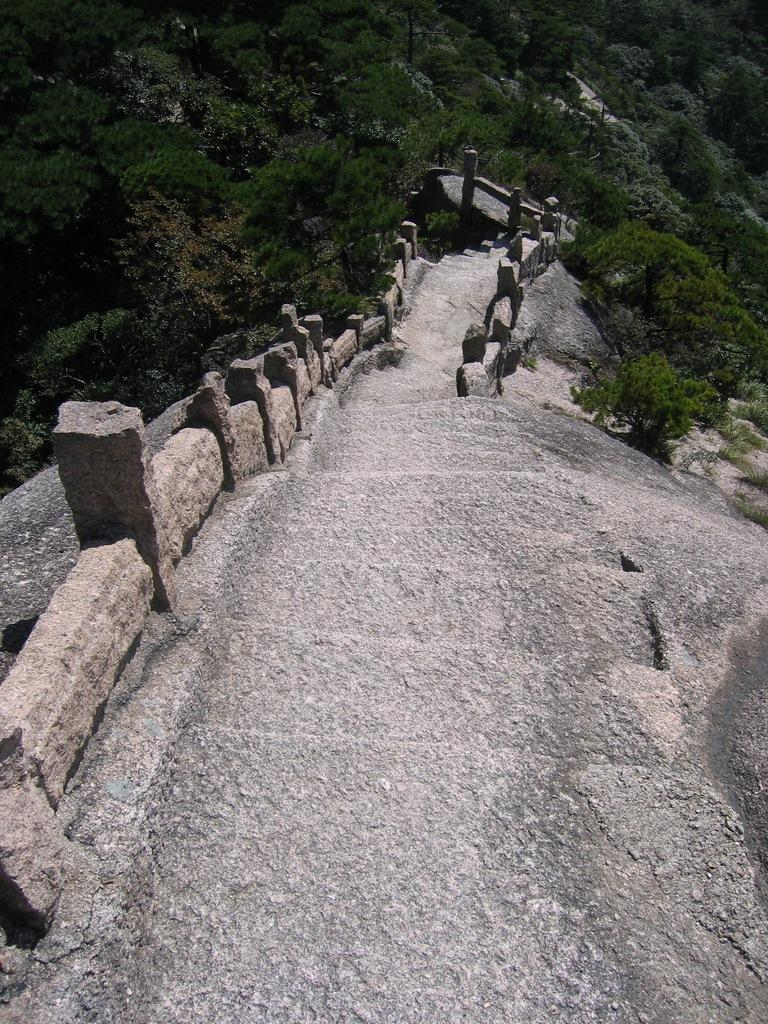What is the main feature in the middle of the image? There is a path in the middle of the image. What can be seen on either side of the path? There are stones on either side of the path. What type of natural scenery is visible in the background? There are trees in the background of the image. What type of badge is visible on the tree in the image? There is no badge present on any tree in the image. What color is the patch on the path in the image? There is no patch visible on the path in the image. 